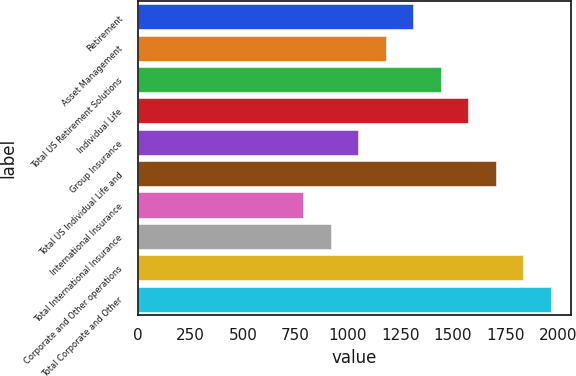Convert chart to OTSL. <chart><loc_0><loc_0><loc_500><loc_500><bar_chart><fcel>Retirement<fcel>Asset Management<fcel>Total US Retirement Solutions<fcel>Individual Life<fcel>Group Insurance<fcel>Total US Individual Life and<fcel>International Insurance<fcel>Total International Insurance<fcel>Corporate and Other operations<fcel>Total Corporate and Other<nl><fcel>1311.01<fcel>1180.14<fcel>1441.88<fcel>1572.75<fcel>1049.28<fcel>1703.62<fcel>787.56<fcel>918.42<fcel>1834.48<fcel>1965.35<nl></chart> 